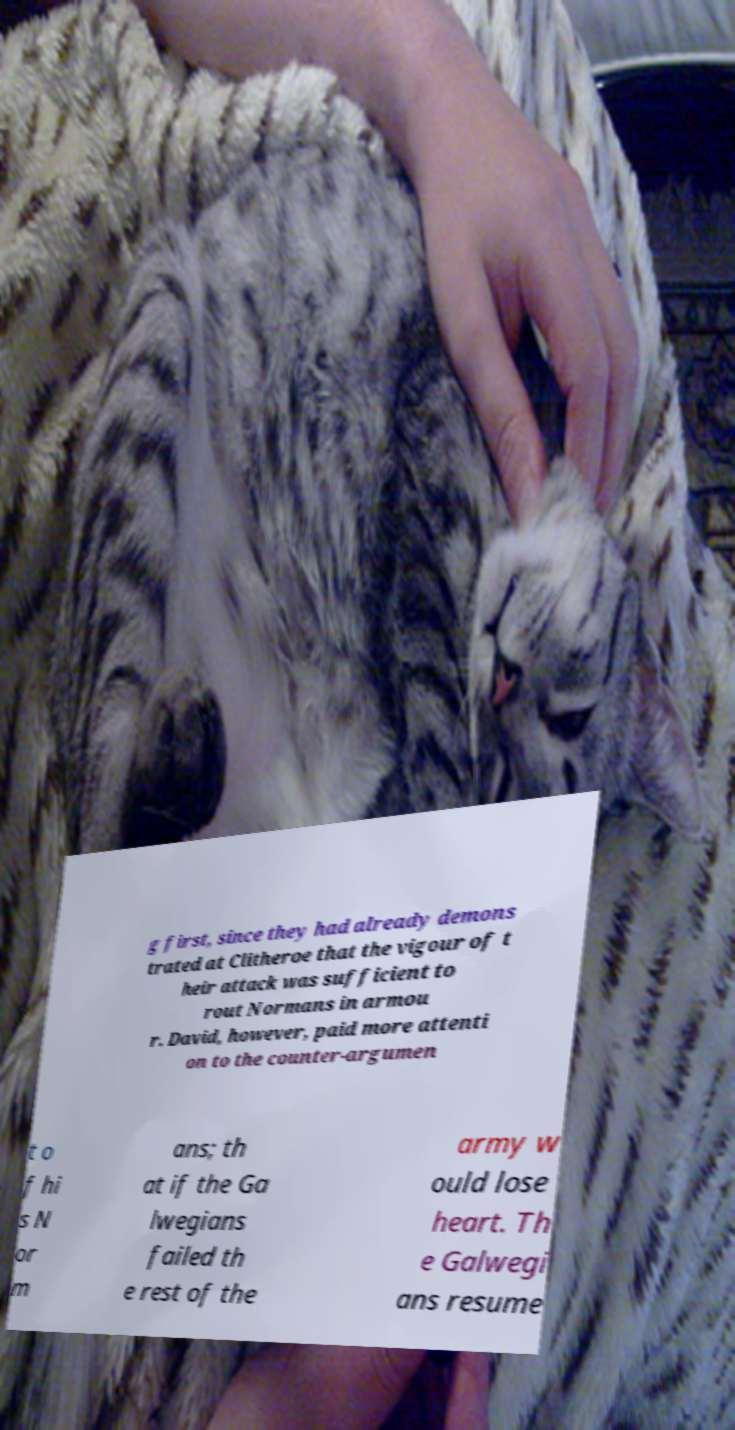For documentation purposes, I need the text within this image transcribed. Could you provide that? g first, since they had already demons trated at Clitheroe that the vigour of t heir attack was sufficient to rout Normans in armou r. David, however, paid more attenti on to the counter-argumen t o f hi s N or m ans; th at if the Ga lwegians failed th e rest of the army w ould lose heart. Th e Galwegi ans resume 